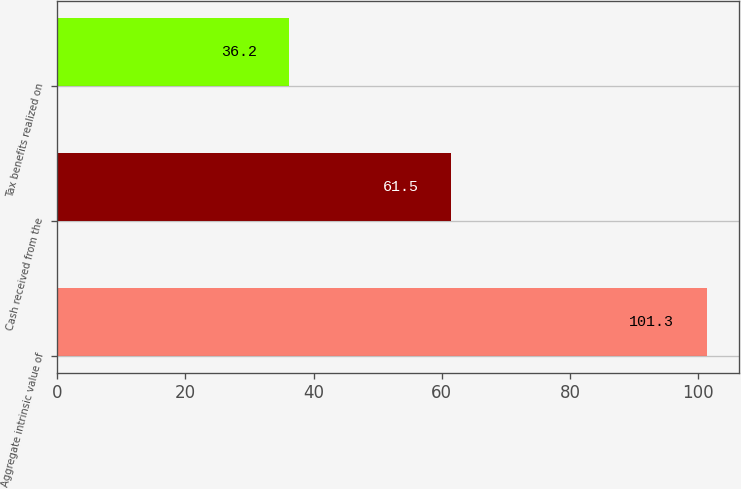Convert chart to OTSL. <chart><loc_0><loc_0><loc_500><loc_500><bar_chart><fcel>Aggregate intrinsic value of<fcel>Cash received from the<fcel>Tax benefits realized on<nl><fcel>101.3<fcel>61.5<fcel>36.2<nl></chart> 